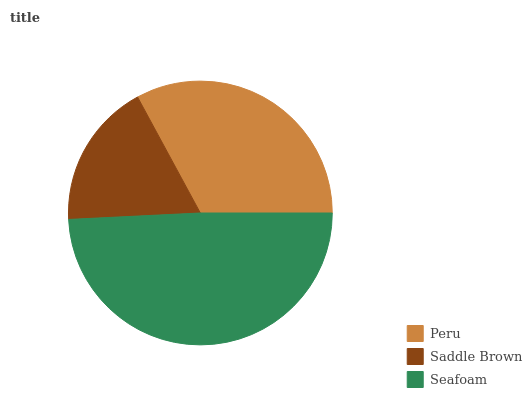Is Saddle Brown the minimum?
Answer yes or no. Yes. Is Seafoam the maximum?
Answer yes or no. Yes. Is Seafoam the minimum?
Answer yes or no. No. Is Saddle Brown the maximum?
Answer yes or no. No. Is Seafoam greater than Saddle Brown?
Answer yes or no. Yes. Is Saddle Brown less than Seafoam?
Answer yes or no. Yes. Is Saddle Brown greater than Seafoam?
Answer yes or no. No. Is Seafoam less than Saddle Brown?
Answer yes or no. No. Is Peru the high median?
Answer yes or no. Yes. Is Peru the low median?
Answer yes or no. Yes. Is Seafoam the high median?
Answer yes or no. No. Is Seafoam the low median?
Answer yes or no. No. 